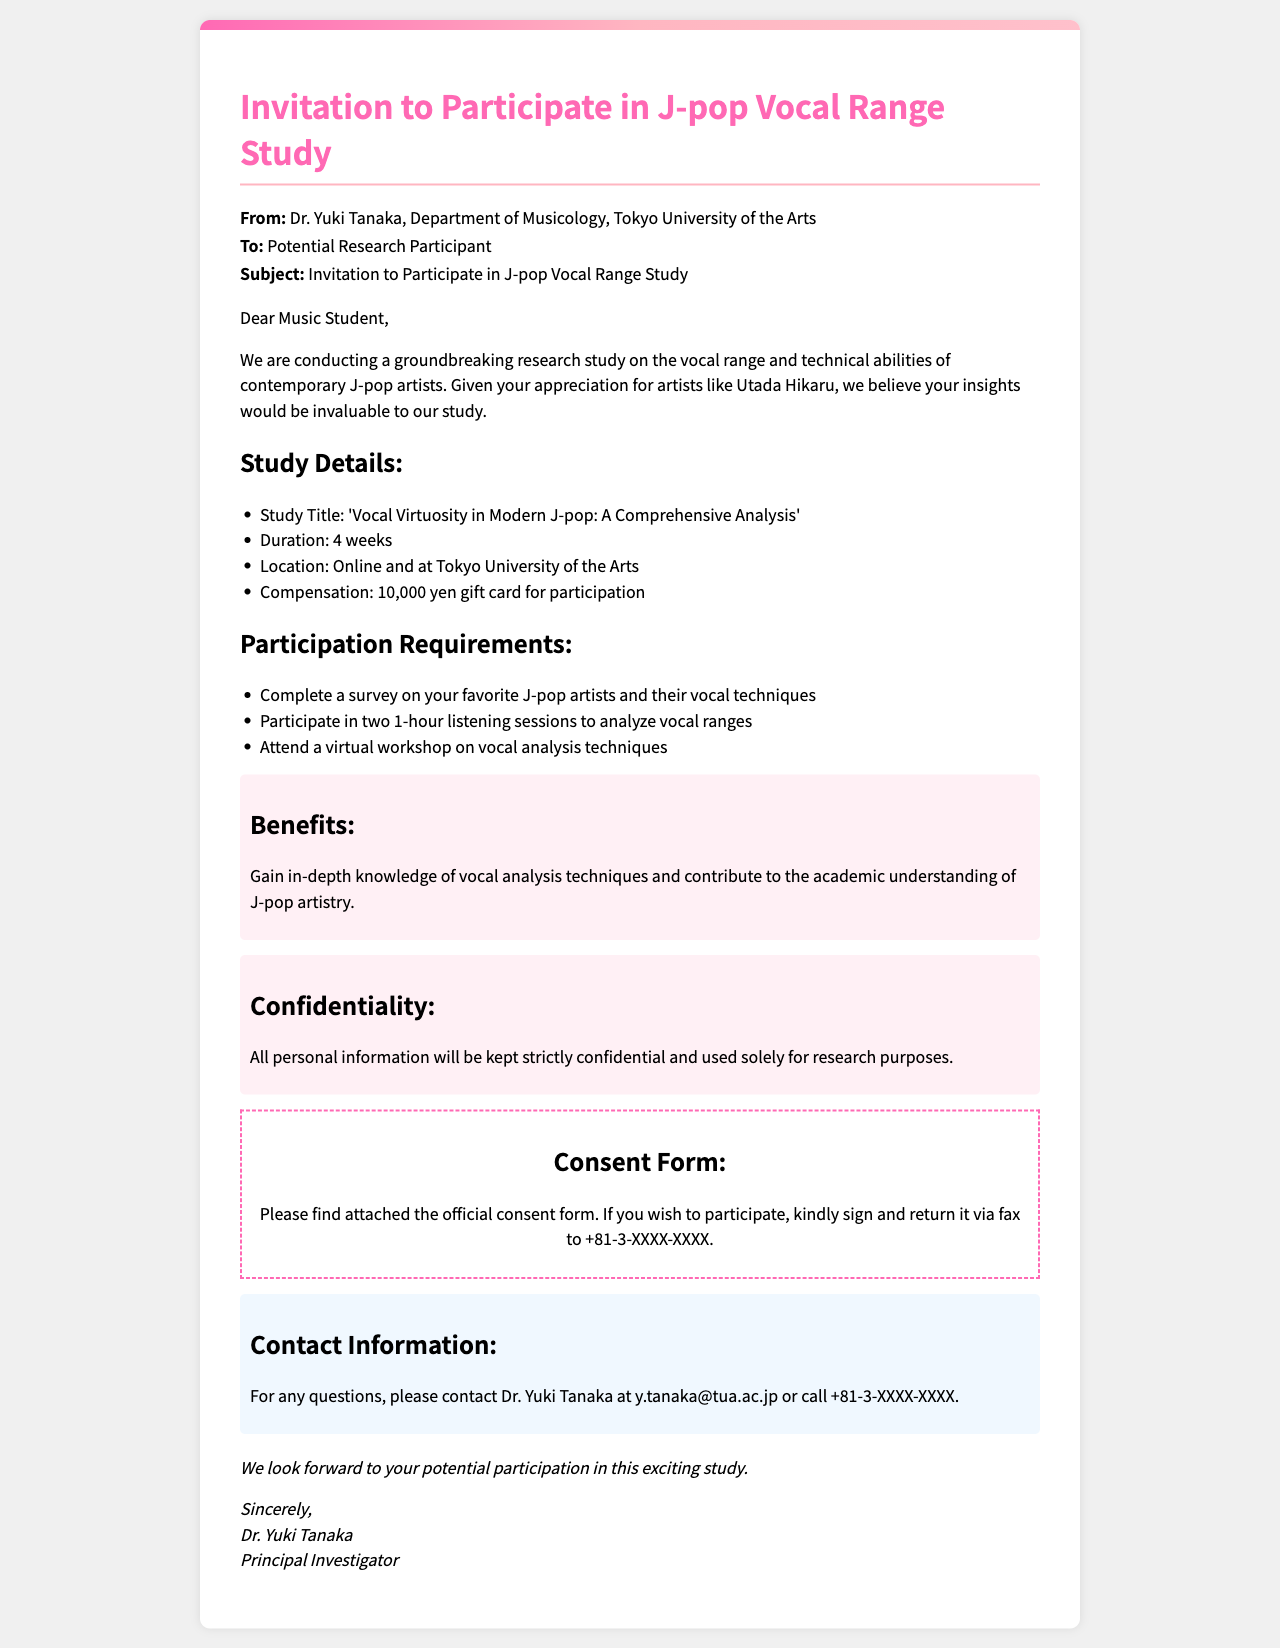What is the title of the study? The title of the study is stated in the study details section of the document.
Answer: 'Vocal Virtuosity in Modern J-pop: A Comprehensive Analysis' Who is the principal investigator? The principal investigator is mentioned at the end of the document.
Answer: Dr. Yuki Tanaka What is the duration of the study? The duration is listed in the study details section.
Answer: 4 weeks How much is the compensation for participation? The compensation amount is specified in the study details.
Answer: 10,000 yen gift card What is one requirement for participation? The requirements are listed as tasks that participants must complete.
Answer: Complete a survey on your favorite J-pop artists and their vocal techniques What are the study locations? The locations for the study are mentioned in the study details section.
Answer: Online and at Tokyo University of the Arts What will participants learn from the study? The benefits outlined in the document highlight what participants will gain.
Answer: Gain in-depth knowledge of vocal analysis techniques How will personal information be treated? The section on confidentiality explains how personal information will be handled.
Answer: Kept strictly confidential What method of return is suggested for the consent form? The document specifies how participants should return the consent form.
Answer: Return it via fax to +81-3-XXXX-XXXX What is the contact method for questions? The contact method is outlined in the contact information section.
Answer: Email or call 